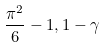<formula> <loc_0><loc_0><loc_500><loc_500>\frac { \pi ^ { 2 } } { 6 } - 1 , 1 - \gamma</formula> 